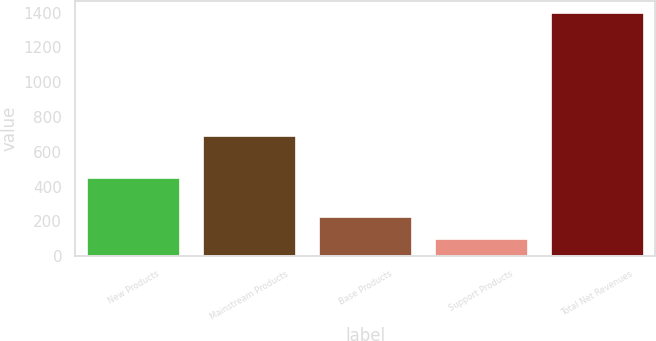<chart> <loc_0><loc_0><loc_500><loc_500><bar_chart><fcel>New Products<fcel>Mainstream Products<fcel>Base Products<fcel>Support Products<fcel>Total Net Revenues<nl><fcel>450.6<fcel>688.5<fcel>226.45<fcel>96.3<fcel>1397.8<nl></chart> 